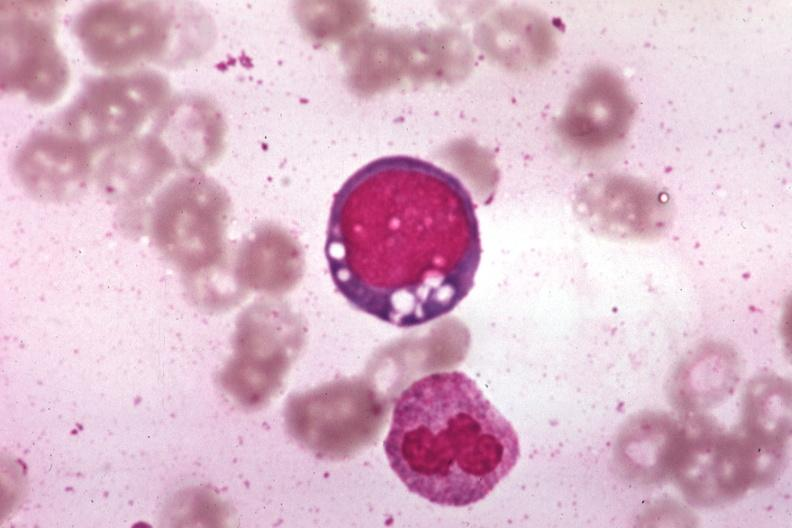does this image show wrights vacuolated erythroblast source unknown?
Answer the question using a single word or phrase. Yes 